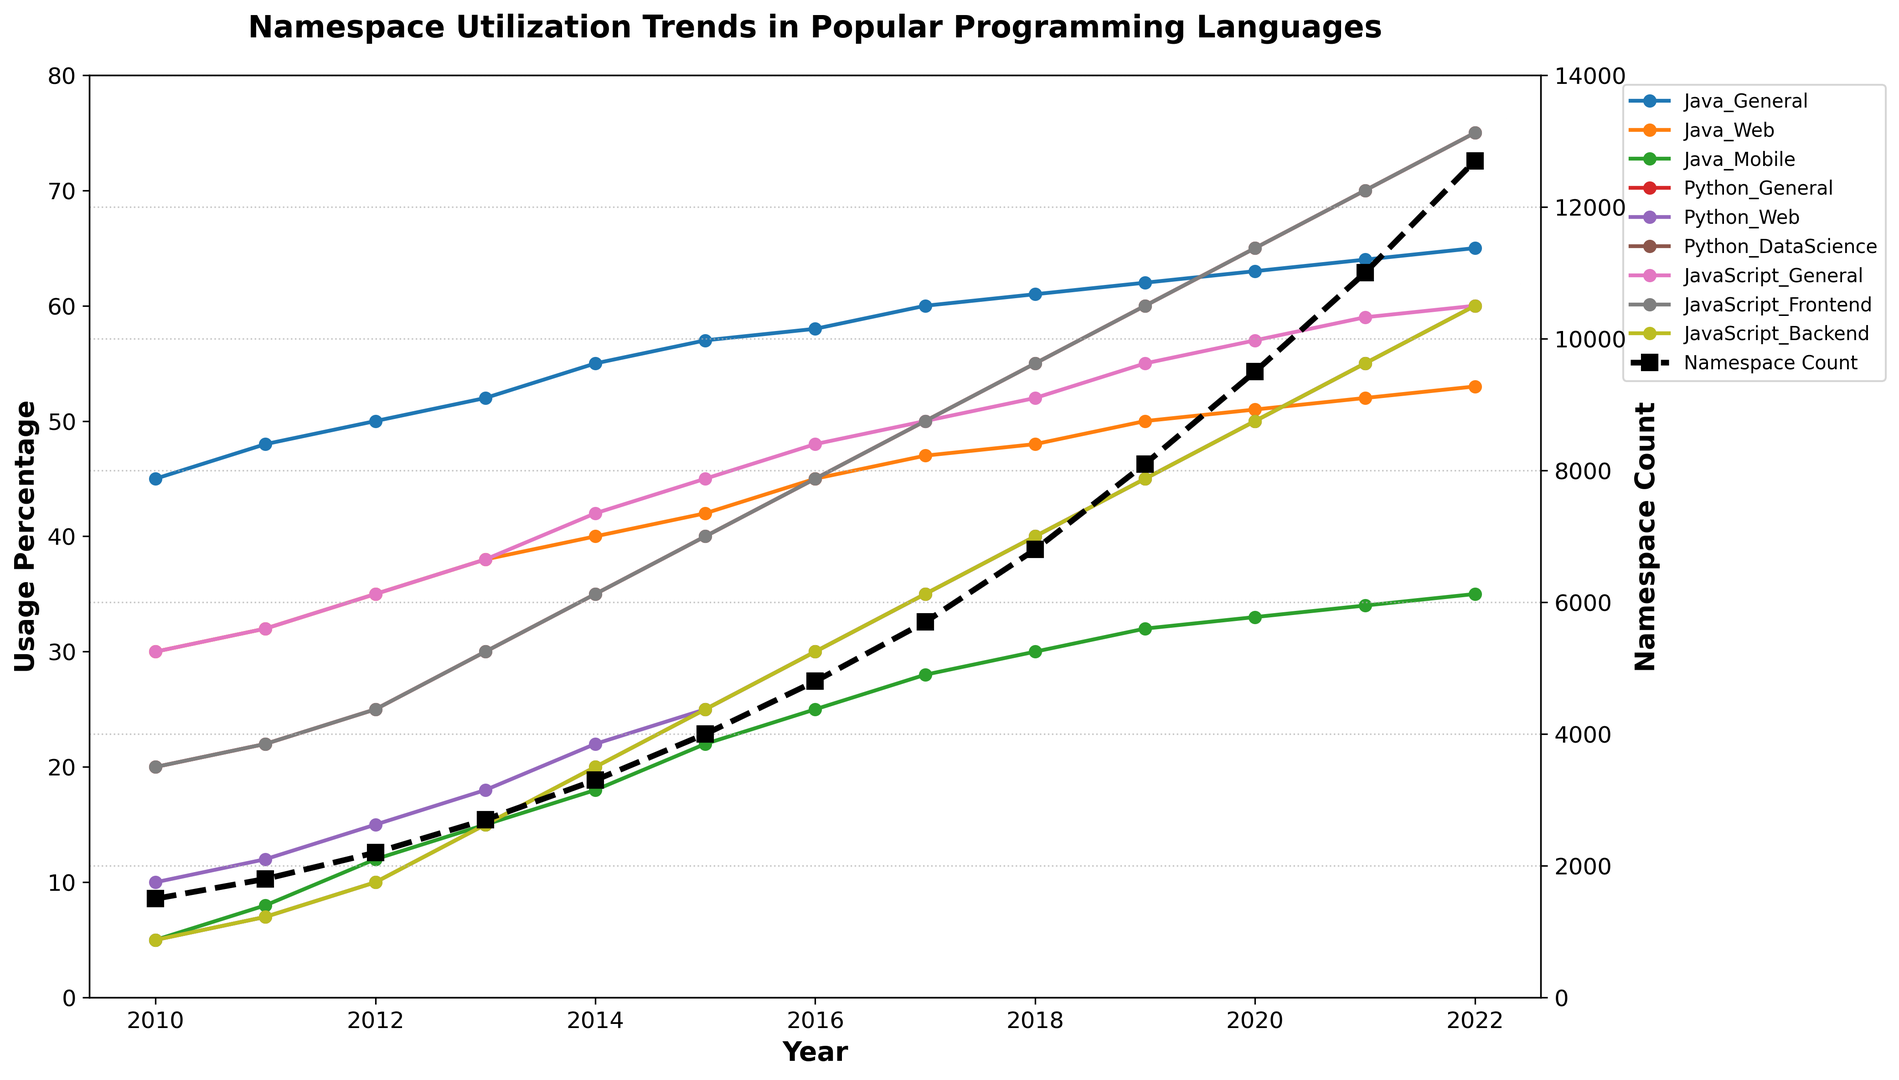How did the usage of Python in web development change from 2010 to 2022? To find the difference in usage, subtract the 2010 value from the 2022 value. According to the figure, in 2010, Python_Web usage was 10, and in 2022, it was 60. Thus, the change is 60 - 10.
Answer: 50 Which year saw the greatest increase in total namespace count compared to the previous year? Identify yearly differences in NamespaceCount and find the year with the largest positive difference. Based on the data: 2022-2021: 1700, 2021-2020: 1500, 2020-2019: 1400, etc. The greatest increase occurred between 2021 and 2022.
Answer: 2022 What is the average usage percentage of Java in mobile applications for the years 2010, 2015, and 2020? To calculate the average, sum the percentages for the given years and divide by the number of years. For Java_Mobile: 2010: 5, 2015: 22, 2020: 33. Average = (5 + 22 + 33) / 3.
Answer: 20 Did any programming language's general usage see a continuous increase from 2010 to 2022? If so, which one? To determine this, check the "General" usage for each language and verify if the percent increases every year. For Java_General, Python_General, and JavaScript_General, all show a continuous increase.
Answer: Java, Python, JavaScript Between 2013 and 2020, which domain experienced more growth in usage percentage, Python in data science or JavaScript in front-end development? Calculate the difference for each domain: Python_DataScience: 50-15=35, JavaScript_Frontend: 65-30=35. Both domains experienced the same growth.
Answer: Both experienced the same In 2017, which programming language had the highest combined usage percentage across all domains, and what was the combined value? Sum the percentages for each language across its domains for 2017. Compare combined values: Java: 60+47+28=135, Python: 50+35+35=120, JavaScript: 50+50+35=135. Java and JavaScript both had the highest combined value of 135 each.
Answer: Java, JavaScript: 135 What was the ratio of the total namespace count in 2022 to that in 2010? To find the ratio, divide the 2022 namespace count by the 2010 namespace count: 12700 / 1500. Simplify the result.
Answer: Approximately 8.47 